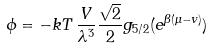<formula> <loc_0><loc_0><loc_500><loc_500>\phi = - k T \, \frac { V } { \lambda ^ { 3 } } \frac { \sqrt { 2 } } { 2 } g _ { 5 / 2 } ( e ^ { \beta ( \mu - v ) } )</formula> 